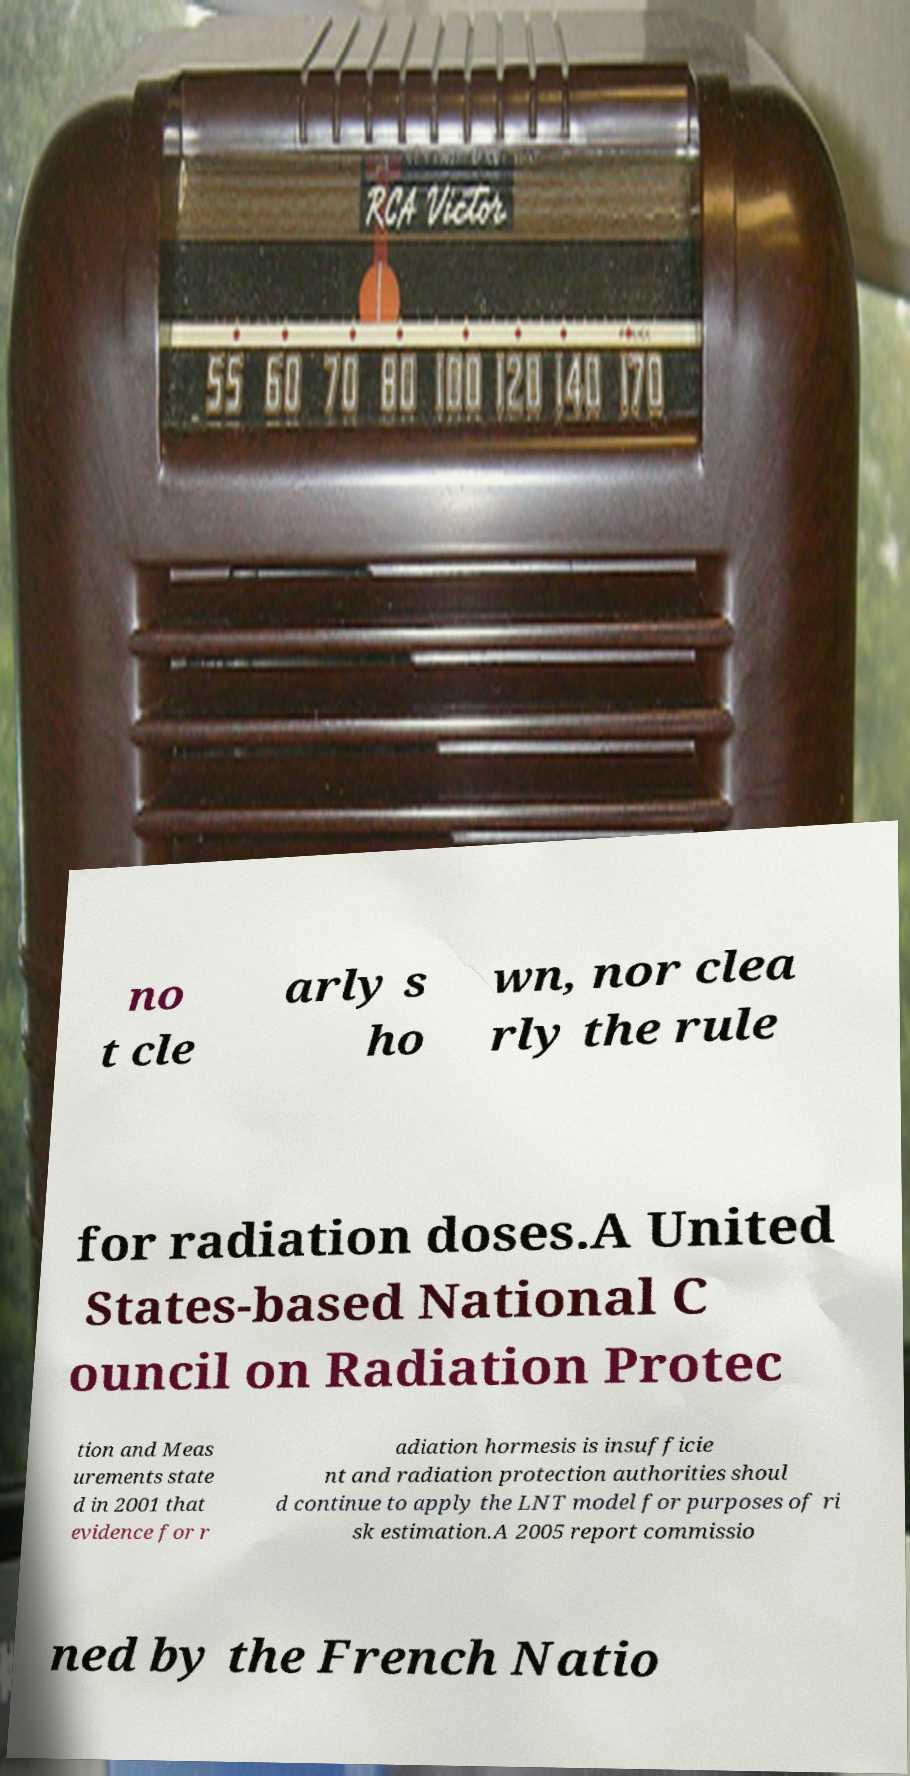There's text embedded in this image that I need extracted. Can you transcribe it verbatim? no t cle arly s ho wn, nor clea rly the rule for radiation doses.A United States-based National C ouncil on Radiation Protec tion and Meas urements state d in 2001 that evidence for r adiation hormesis is insufficie nt and radiation protection authorities shoul d continue to apply the LNT model for purposes of ri sk estimation.A 2005 report commissio ned by the French Natio 